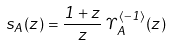<formula> <loc_0><loc_0><loc_500><loc_500>s _ { A } ( z ) = \frac { 1 + z } { z } \, \Upsilon _ { A } ^ { \langle - 1 \rangle } ( z )</formula> 